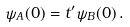<formula> <loc_0><loc_0><loc_500><loc_500>\psi _ { A } ( 0 ) = t ^ { \prime } \psi _ { B } ( 0 ) \, .</formula> 